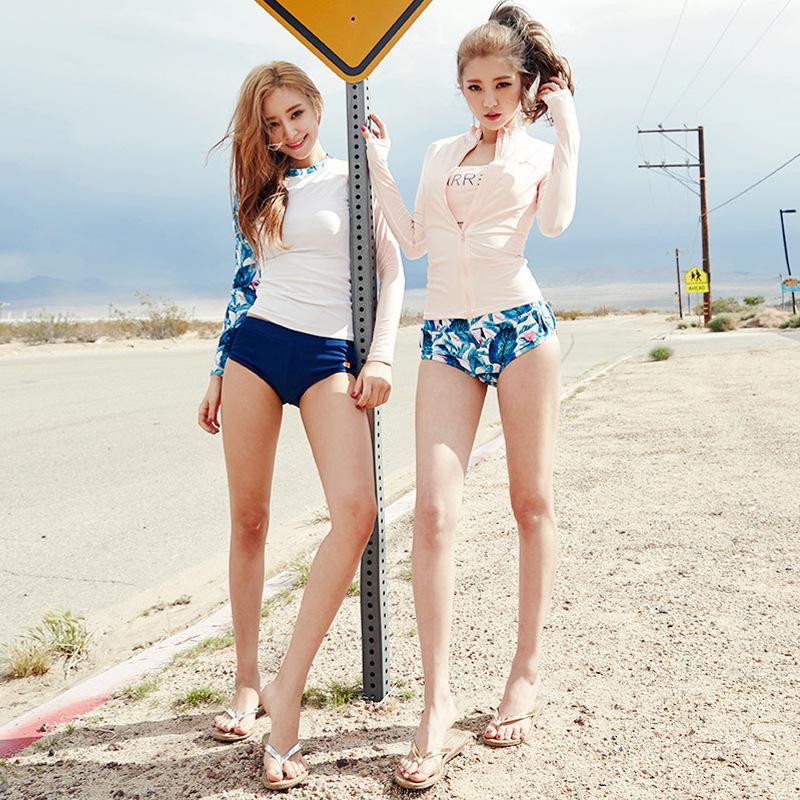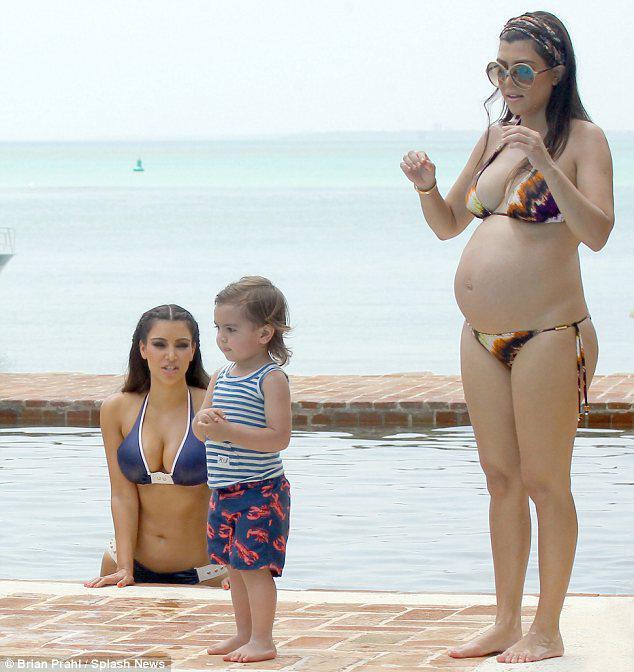The first image is the image on the left, the second image is the image on the right. Evaluate the accuracy of this statement regarding the images: "One of the women is wearing a bright pink two piece bikini.". Is it true? Answer yes or no. No. The first image is the image on the left, the second image is the image on the right. Considering the images on both sides, is "Three girls stand side-by-side in bikini tops, and all wear the same color bottoms." valid? Answer yes or no. No. 